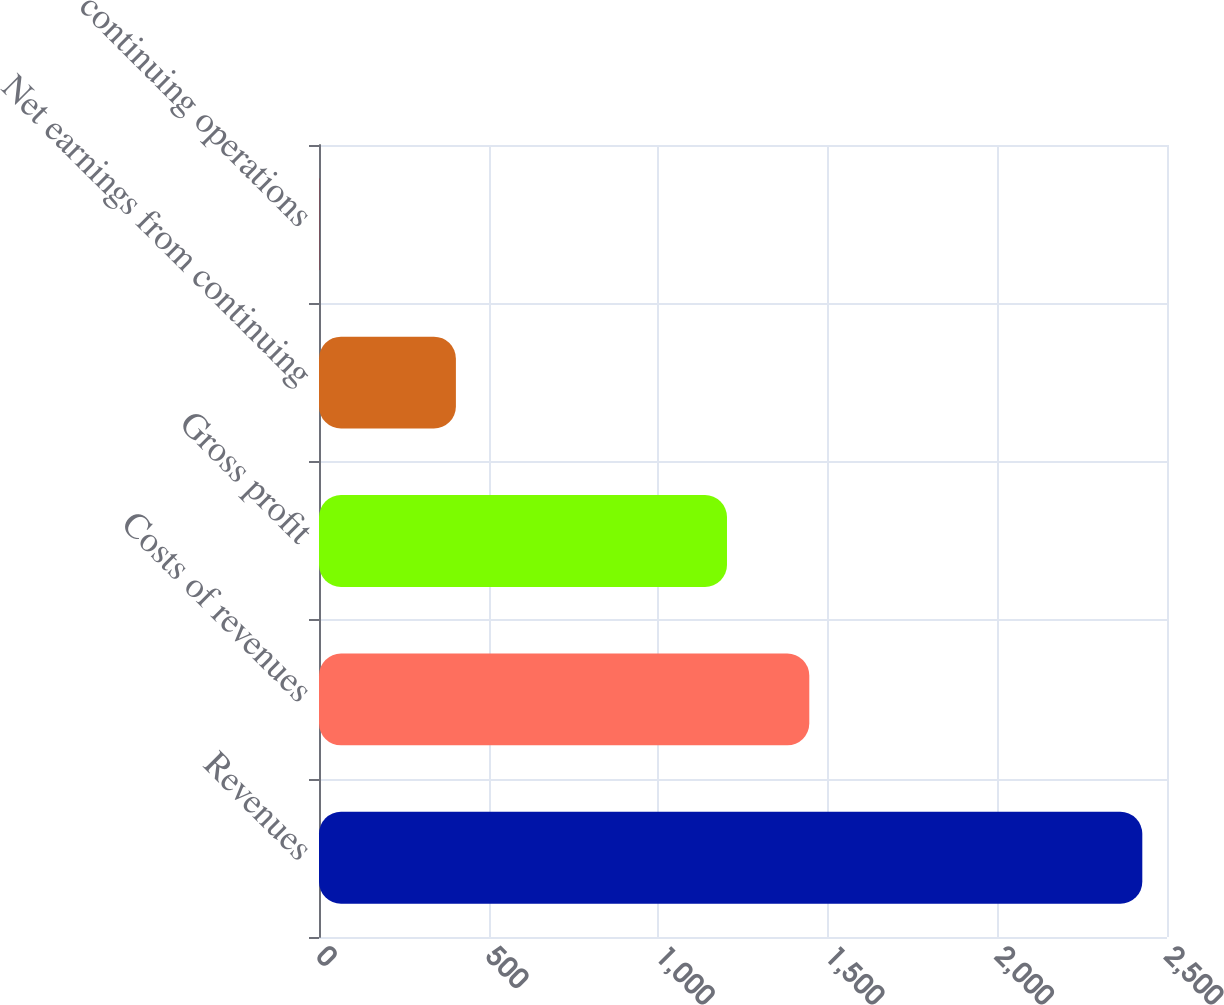<chart> <loc_0><loc_0><loc_500><loc_500><bar_chart><fcel>Revenues<fcel>Costs of revenues<fcel>Gross profit<fcel>Net earnings from continuing<fcel>continuing operations<nl><fcel>2427.2<fcel>1445.44<fcel>1202.8<fcel>403.6<fcel>0.78<nl></chart> 